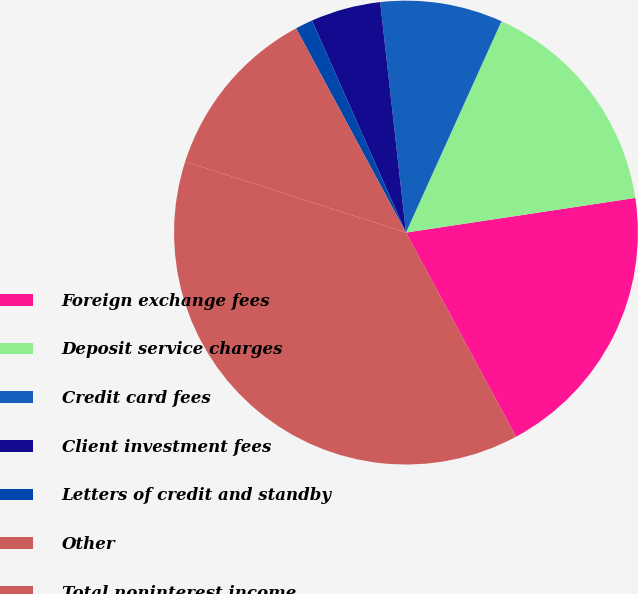<chart> <loc_0><loc_0><loc_500><loc_500><pie_chart><fcel>Foreign exchange fees<fcel>Deposit service charges<fcel>Credit card fees<fcel>Client investment fees<fcel>Letters of credit and standby<fcel>Other<fcel>Total noninterest income<nl><fcel>19.52%<fcel>15.86%<fcel>8.53%<fcel>4.87%<fcel>1.21%<fcel>12.19%<fcel>37.83%<nl></chart> 